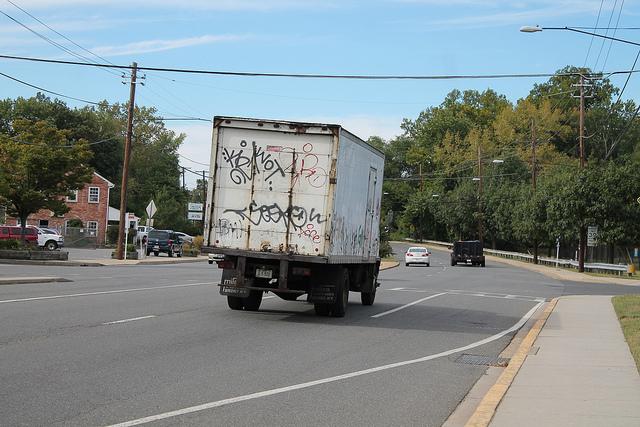Is there graffiti on the moving truck?
Write a very short answer. Yes. Is the truck driving down the street?
Concise answer only. Yes. What color are the trees?
Be succinct. Green. 